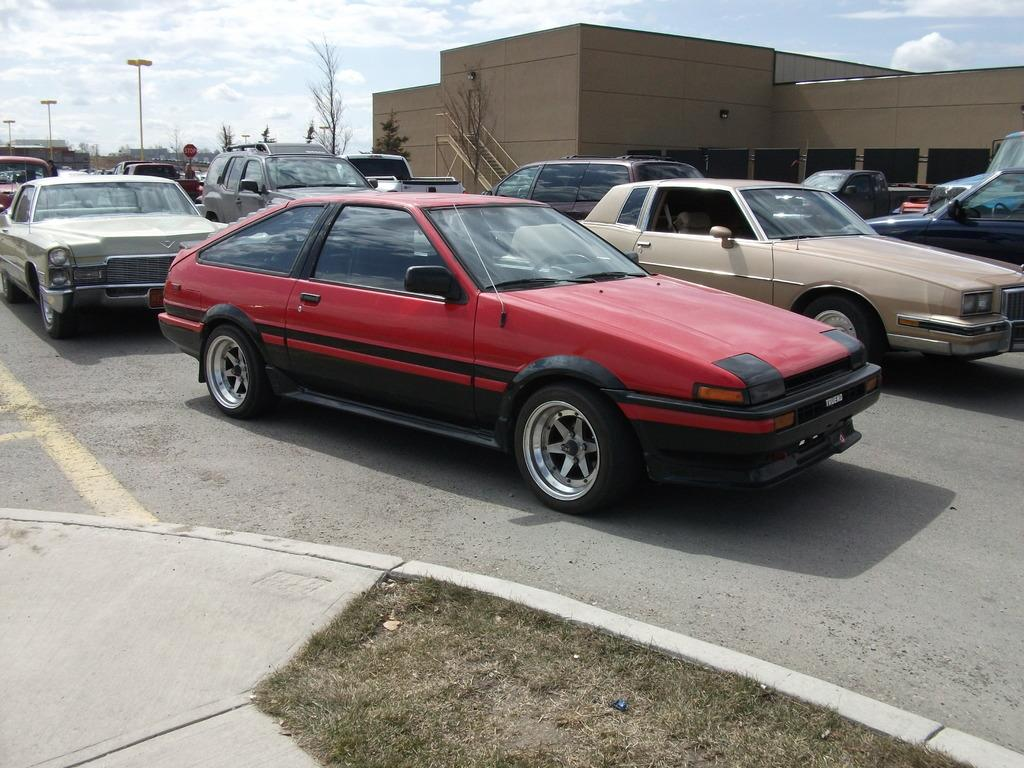What type of vehicles can be seen on the road in the image? There are cars on the road in the image. What is located in the background of the image? There is a building, poles, trees, and the sky visible in the background of the image. What type of wool can be seen on the cars in the image? There is no wool present on the cars in the image. What appliance is being used by the flock of birds in the image? There are no birds or appliances present in the image. 